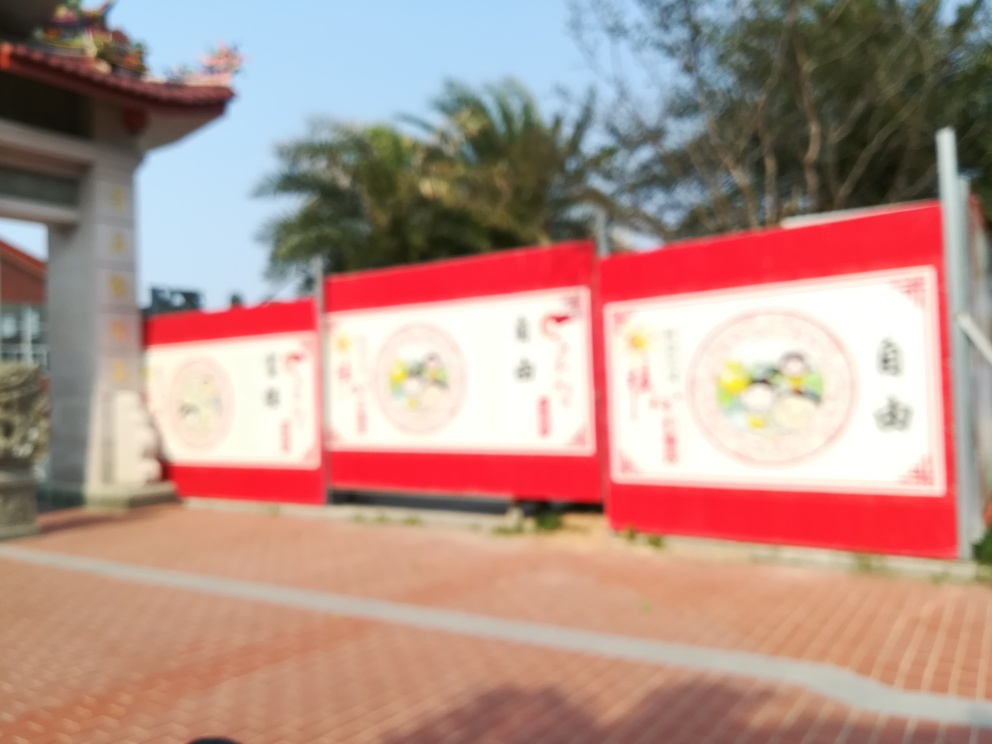What might be the significance of the red and white colors on the billboard? Red and white are often colors of contrast, with red commonly symbolizing passion, energy, and importance, while white can signify purity, clarity, and simplicity. Together on a billboard, they create a striking visual that can be attention-grabbing and memorable, possibly conveying a message of vital importance or celebration. 